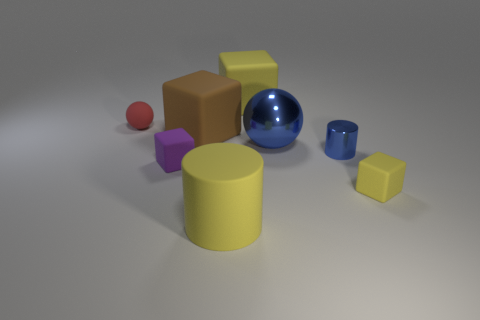Subtract 1 blocks. How many blocks are left? 3 Subtract all cyan cubes. Subtract all brown spheres. How many cubes are left? 4 Add 1 gray objects. How many objects exist? 9 Subtract all balls. How many objects are left? 6 Add 2 small gray shiny objects. How many small gray shiny objects exist? 2 Subtract 1 brown blocks. How many objects are left? 7 Subtract all cubes. Subtract all small purple cubes. How many objects are left? 3 Add 3 yellow rubber cylinders. How many yellow rubber cylinders are left? 4 